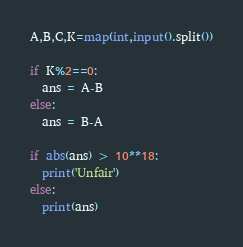Convert code to text. <code><loc_0><loc_0><loc_500><loc_500><_Python_>A,B,C,K=map(int,input().split())

if K%2==0:
  ans = A-B
else:
  ans = B-A

if abs(ans) > 10**18:
  print('Unfair')
else:
  print(ans)</code> 